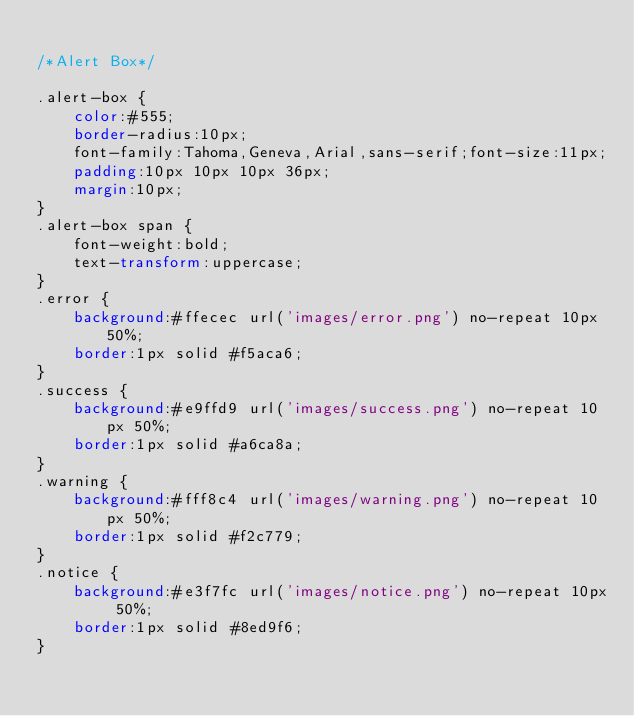<code> <loc_0><loc_0><loc_500><loc_500><_CSS_>
/*Alert Box*/

.alert-box {
    color:#555;
    border-radius:10px;
    font-family:Tahoma,Geneva,Arial,sans-serif;font-size:11px;
    padding:10px 10px 10px 36px;
    margin:10px;
}
.alert-box span {
    font-weight:bold;
    text-transform:uppercase;
}
.error {
    background:#ffecec url('images/error.png') no-repeat 10px 50%;
    border:1px solid #f5aca6;
}
.success {
    background:#e9ffd9 url('images/success.png') no-repeat 10px 50%;
    border:1px solid #a6ca8a;
}
.warning {
    background:#fff8c4 url('images/warning.png') no-repeat 10px 50%;
    border:1px solid #f2c779;
}
.notice {
    background:#e3f7fc url('images/notice.png') no-repeat 10px 50%;
    border:1px solid #8ed9f6;
}
</code> 